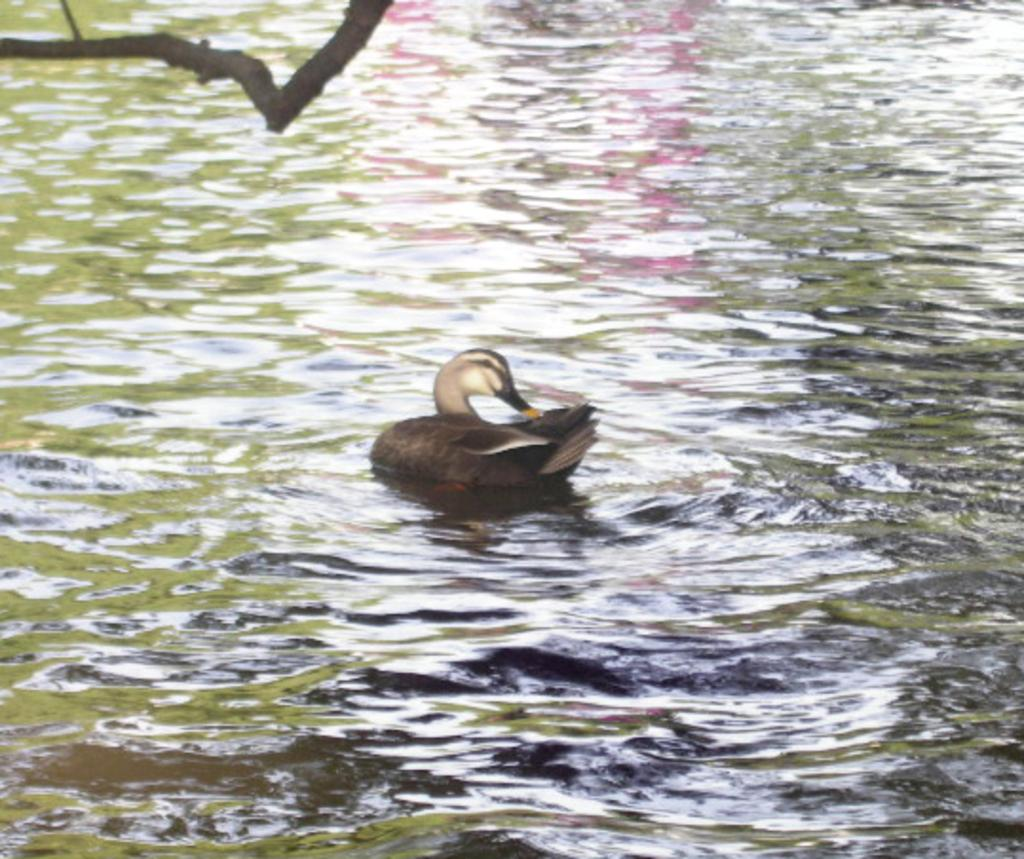What type of animal is in the image? There is a bird in the image. Where is the bird located? The bird is on the water. What colors can be seen on the bird? The bird has black and cream coloring. What is visible to the left of the image? There is a tree branch visible to the left of the image. What type of furniture can be seen in the image? There is no furniture present in the image; it features a bird on the water. How many icicles are hanging from the bird in the image? There are no icicles present in the image; the bird has black and cream coloring. 